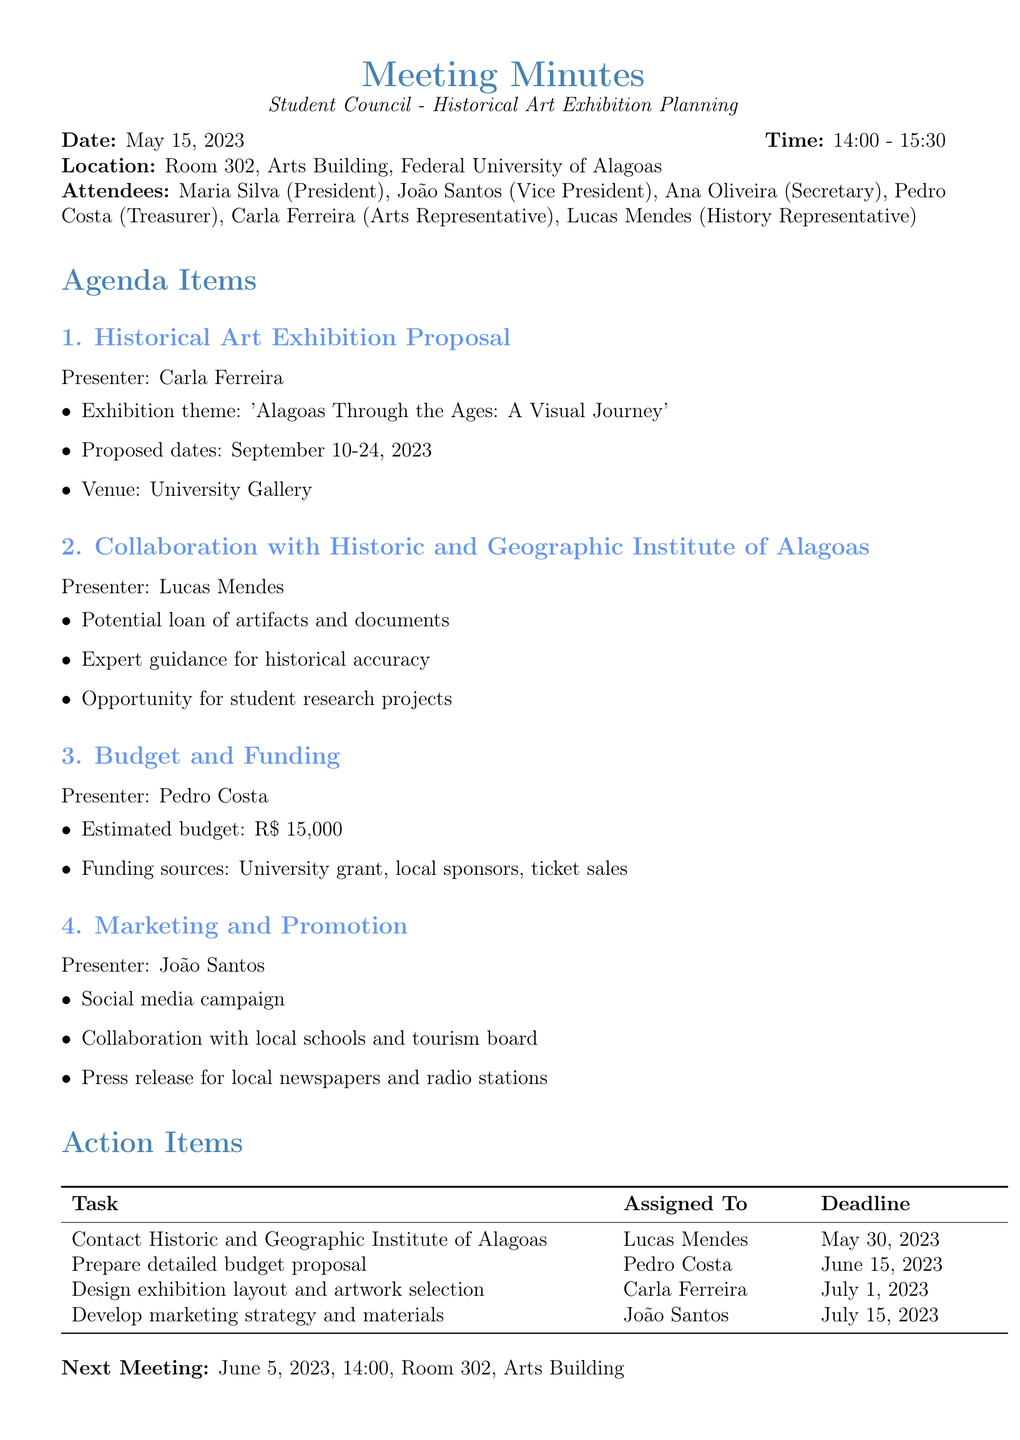What is the date of the meeting? The date of the meeting is explicitly stated in the document under the meeting details section.
Answer: May 15, 2023 Who presented the Historical Art Exhibition Proposal? The presenter of the Historical Art Exhibition Proposal is listed in the agenda items section of the document.
Answer: Carla Ferreira What are the proposed dates for the exhibition? The proposed dates for the exhibition are mentioned in the key points of the first agenda item.
Answer: September 10-24, 2023 What is the estimated budget for the exhibition? The estimated budget is provided in the Budget and Funding section of the agenda.
Answer: R$ 15,000 Who is assigned to contact the Historic and Geographic Institute of Alagoas? The action item regarding contacting the Institute includes the name of the person responsible, as detailed in the action items section.
Answer: Lucas Mendes What is one of the marketing strategies mentioned? The marketing strategies discussed are outlined by João Santos in the marketing agenda item.
Answer: Social media campaign When is the next meeting scheduled? The date and time of the next meeting are clearly indicated at the end of the minutes.
Answer: June 5, 2023 What is the venue for the exhibition? The venue is explicitly stated in the proposal details within the document.
Answer: University Gallery 